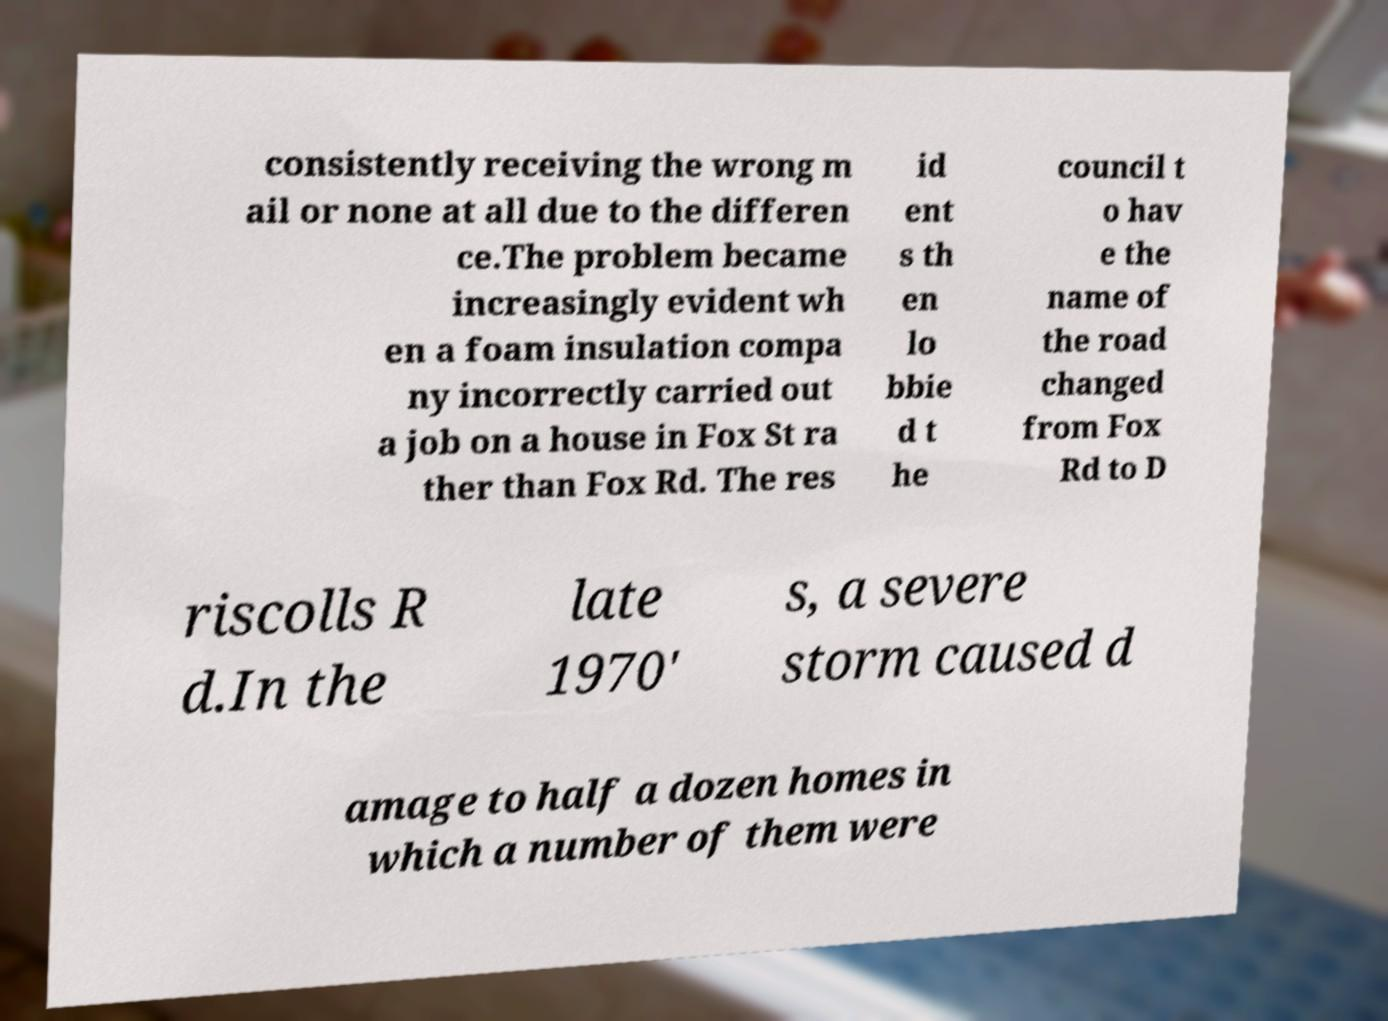Can you read and provide the text displayed in the image?This photo seems to have some interesting text. Can you extract and type it out for me? consistently receiving the wrong m ail or none at all due to the differen ce.The problem became increasingly evident wh en a foam insulation compa ny incorrectly carried out a job on a house in Fox St ra ther than Fox Rd. The res id ent s th en lo bbie d t he council t o hav e the name of the road changed from Fox Rd to D riscolls R d.In the late 1970' s, a severe storm caused d amage to half a dozen homes in which a number of them were 